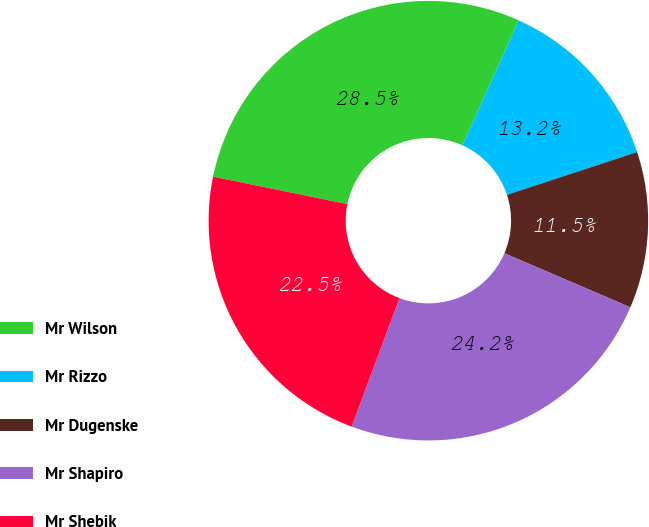Convert chart to OTSL. <chart><loc_0><loc_0><loc_500><loc_500><pie_chart><fcel>Mr Wilson<fcel>Mr Rizzo<fcel>Mr Dugenske<fcel>Mr Shapiro<fcel>Mr Shebik<nl><fcel>28.53%<fcel>13.2%<fcel>11.5%<fcel>24.23%<fcel>22.53%<nl></chart> 